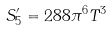Convert formula to latex. <formula><loc_0><loc_0><loc_500><loc_500>S _ { 5 } ^ { \prime } = 2 8 8 \pi ^ { 6 } T ^ { 3 }</formula> 